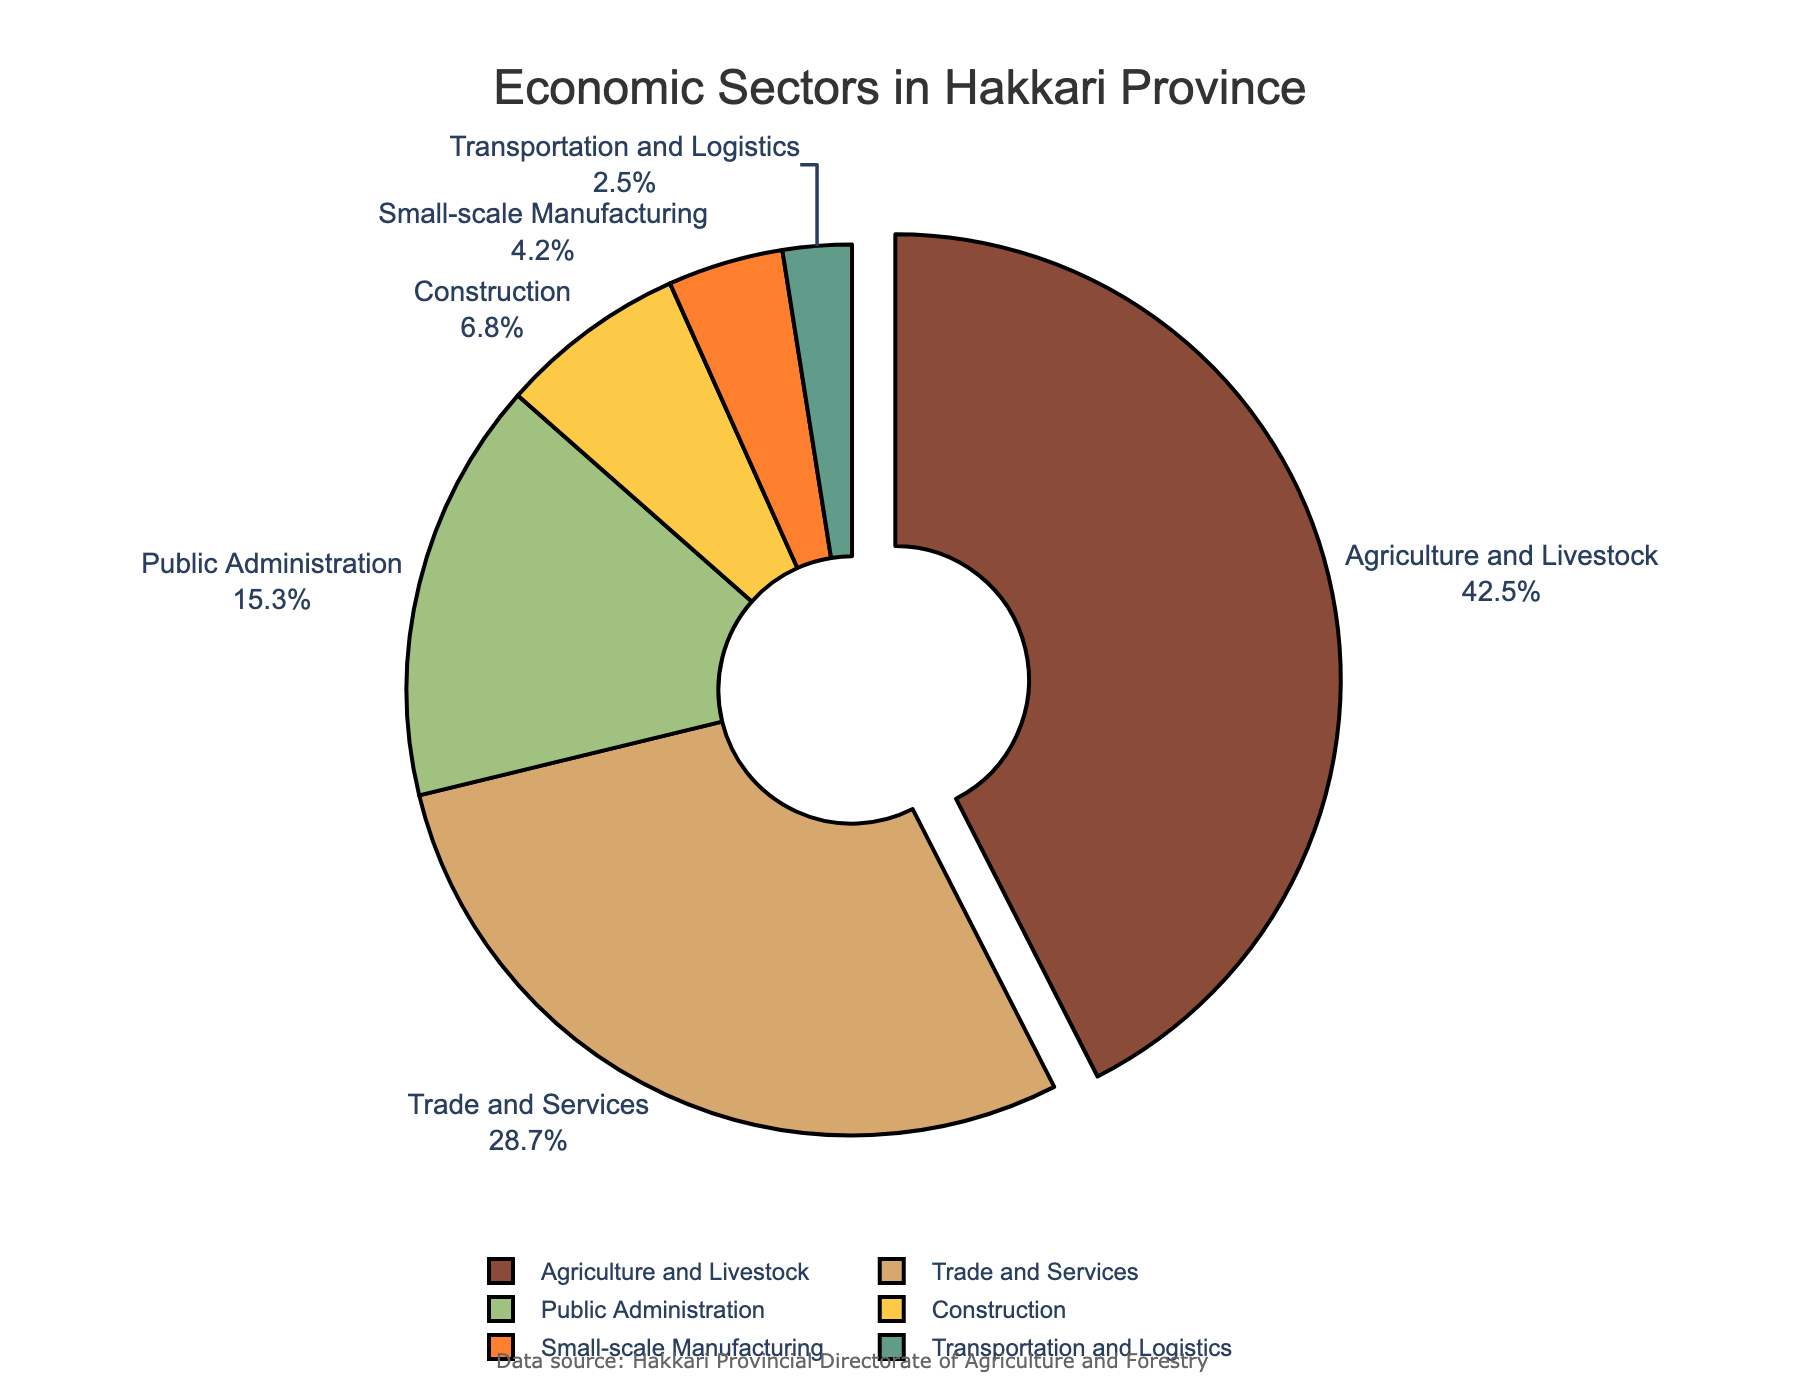What percentage of Hakkari's economy is comprised of Agriculture and Livestock and Public Administration combined? Add the percentages of Agriculture and Livestock (42.5%) and Public Administration (15.3%). Thus, 42.5 + 15.3 = 57.8%.
Answer: 57.8% Which sector has the smallest share in Hakkari's economy? The sector with the smallest percentage value in the chart is Transportation and Logistics at 2.5%.
Answer: Transportation and Logistics Is the share of the Agriculture and Livestock sector greater than the combined share of Trade and Services, and Small-scale Manufacturing? Sum the percentages of Trade and Services (28.7%) and Small-scale Manufacturing (4.2%). Thus, 28.7 + 4.2 = 32.9%. Compare this with the percentage of Agriculture and Livestock (42.5%), which is greater than 32.9%.
Answer: Yes What is the difference in the percentage share between Trade and Services and Construction? Subtract the percentage of Construction (6.8%) from the percentage of Trade and Services (28.7%). Thus, 28.7% - 6.8% = 21.9%.
Answer: 21.9% What sectors make up over half of Hakkari's economy? Look at the sectors with the highest percentages and sum them. Agriculture and Livestock (42.5%) and Trade and Services (28.7%) are both needed to surpass half (50%) of Hakkari’s economy.
Answer: Agriculture and Livestock, Trade and Services What percentage of the economy is made up by the non-service sectors (Agriculture and Livestock, Construction, Small-scale Manufacturing, Transportation and Logistics)? Sum the percentages of Agriculture and Livestock (42.5%), Construction (6.8%), Small-scale Manufacturing (4.2%), and Transportation and Logistics (2.5%). Thus, 42.5 + 6.8 + 4.2 + 2.5 = 56%.
Answer: 56% In terms of visual interpretation, what is the color representing the Construction sector? The sector Construction is represented by the fourth color in the list provided, which is yellow.
Answer: Yellow 